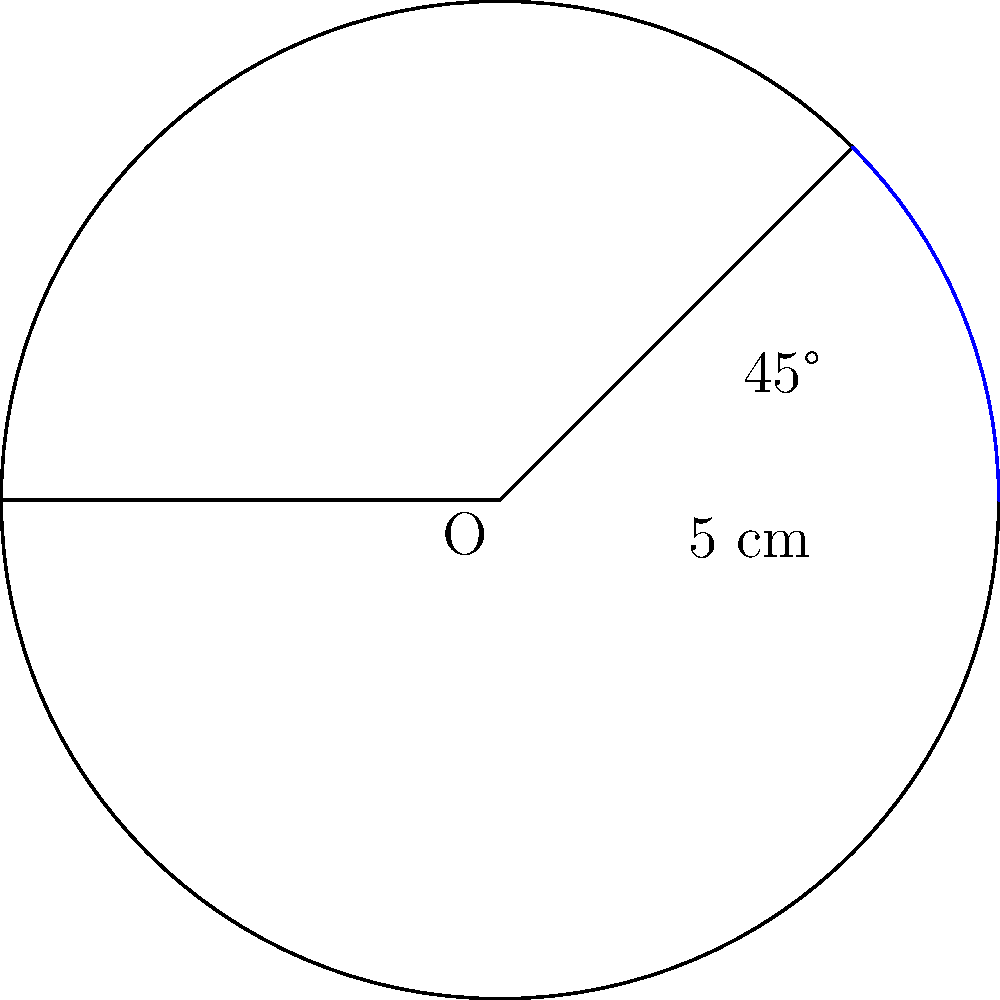As a retired DJ, you're inspecting your vintage turntable. The platter has a radius of 5 cm. If the tonearm sweeps an angle of 45°, what is the area of the sector traced by the stylus on the record surface? Round your answer to two decimal places. Let's approach this step-by-step:

1) The formula for the area of a sector is:
   $$A = \frac{1}{2}r^2\theta$$
   where $r$ is the radius and $\theta$ is the angle in radians.

2) We're given the radius $r = 5$ cm and the angle of 45°.

3) First, we need to convert 45° to radians:
   $$45° \times \frac{\pi}{180°} = \frac{\pi}{4} \text{ radians}$$

4) Now we can substitute these values into our formula:
   $$A = \frac{1}{2} \times 5^2 \times \frac{\pi}{4}$$

5) Simplify:
   $$A = \frac{25\pi}{8} \text{ cm}^2$$

6) Calculate and round to two decimal places:
   $$A \approx 9.82 \text{ cm}^2$$
Answer: 9.82 cm² 